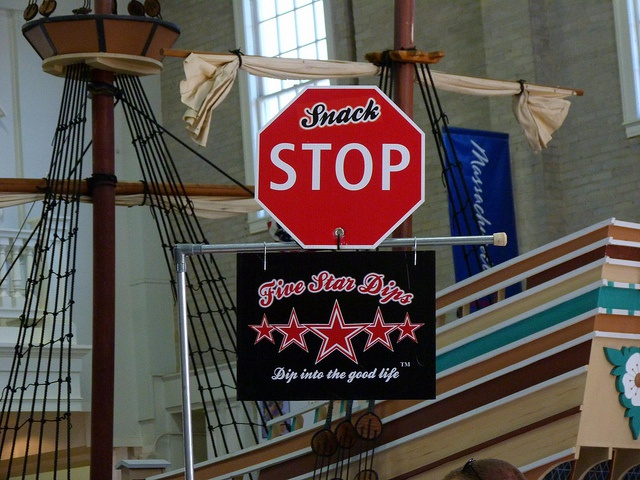Describe the objects in this image and their specific colors. I can see stop sign in gray, brown, darkgray, lavender, and lightgray tones and people in gray, black, and maroon tones in this image. 